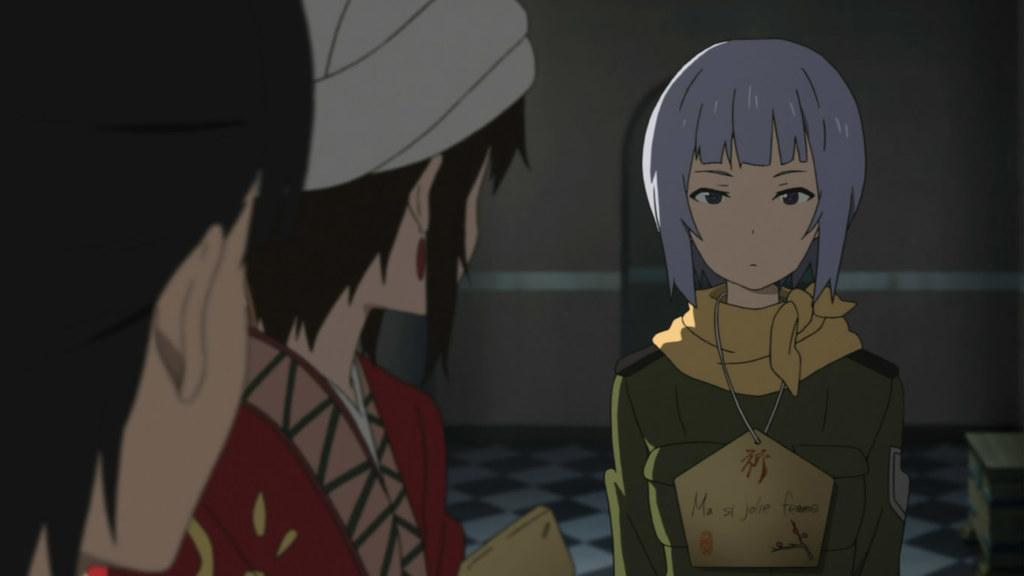What type of image is being described? The image is animated. Where are the two people located in the image? The two people are on the left side of the image. What is the position of the person in the center of the image? A person is standing in the center of the image. What can be seen on the person in the center? The person in the center is wearing an ID card. What is present at the back of the image? There is a wall at the back of the image. What is the plot of the animated show in the image? The provided facts do not give any information about the plot of the animated show in the image. 